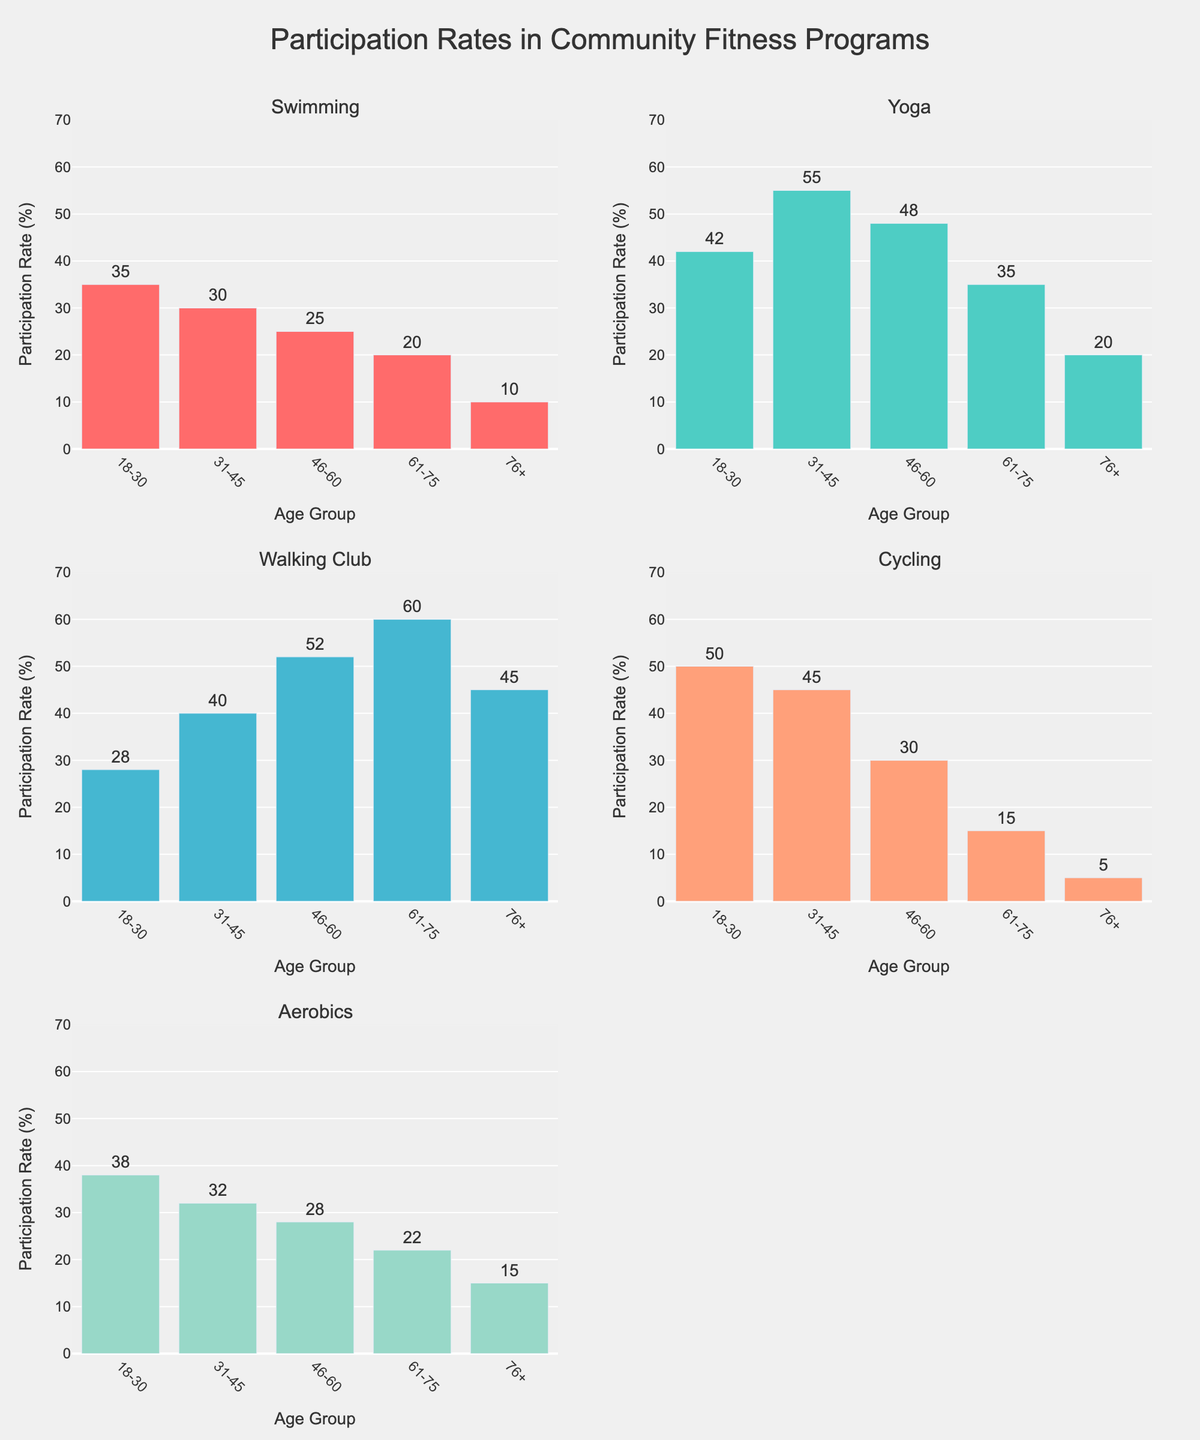Which age group has the highest participation rate in Swimming? Look at the bar in the Swimming subplot for each age group, and find the one with the highest value. The group 18-30 has the highest bar with a value of 35.
Answer: 18-30 What is the title of the figure? Read the text at the top of the figure. It states: "Participation Rates in Community Fitness Programs".
Answer: Participation Rates in Community Fitness Programs How many different fitness programs are analyzed in the figure? Count the number of subplots, each representing a different fitness program. There are five subplots.
Answer: 5 What is the average participation rate for Yoga across all age groups? Add the participation rates for Yoga (42, 55, 48, 35, 20) and divide by the number of groups (5): (42 + 55 + 48 + 35 + 20) / 5 = 40.
Answer: 40 Which fitness program has the lowest participation rate in the 76+ age group? Look at the bars in the 76+ group for each subplot and find the lowest one. The Cycling program has the lowest rate with a value of 5.
Answer: Cycling How much higher is the participation rate for Walking Club in the 61-75 group compared to the 31-45 group? Subtract the participation rate of Walking Club in the 31-45 group from that in the 61-75 group: 60 - 40 = 20.
Answer: 20 Which two age groups have the same participation rate for Aerobics? Look for bars with the same height in the Aerobics subplot. Both the 31-45 and 46-60 groups have a participation rate of 32.
Answer: 31-45 and 46-60 What is the range of participation rates for Cycling across all age groups? Find the highest and lowest participation rates for Cycling across all age groups: highest is 50, lowest is 5; range = 50 - 5 = 45.
Answer: 45 In which age group is Yoga the most popular fitness program compared to its other programs? Identify the subplot for Yoga and find the age group with the highest participation rate; then compare this rate with other fitness programs in that age group. The 31-45 group has the highest rate for Yoga (55), which is the highest among its other programs.
Answer: 31-45 What is the difference in participation rates between the most popular and least popular fitness programs in the 18-30 age group? Identify the highest and lowest participation rates for 18-30 across all subplots: most popular is Cycling (50), least popular is Walking Club (28); difference = 50 - 28 = 22.
Answer: 22 